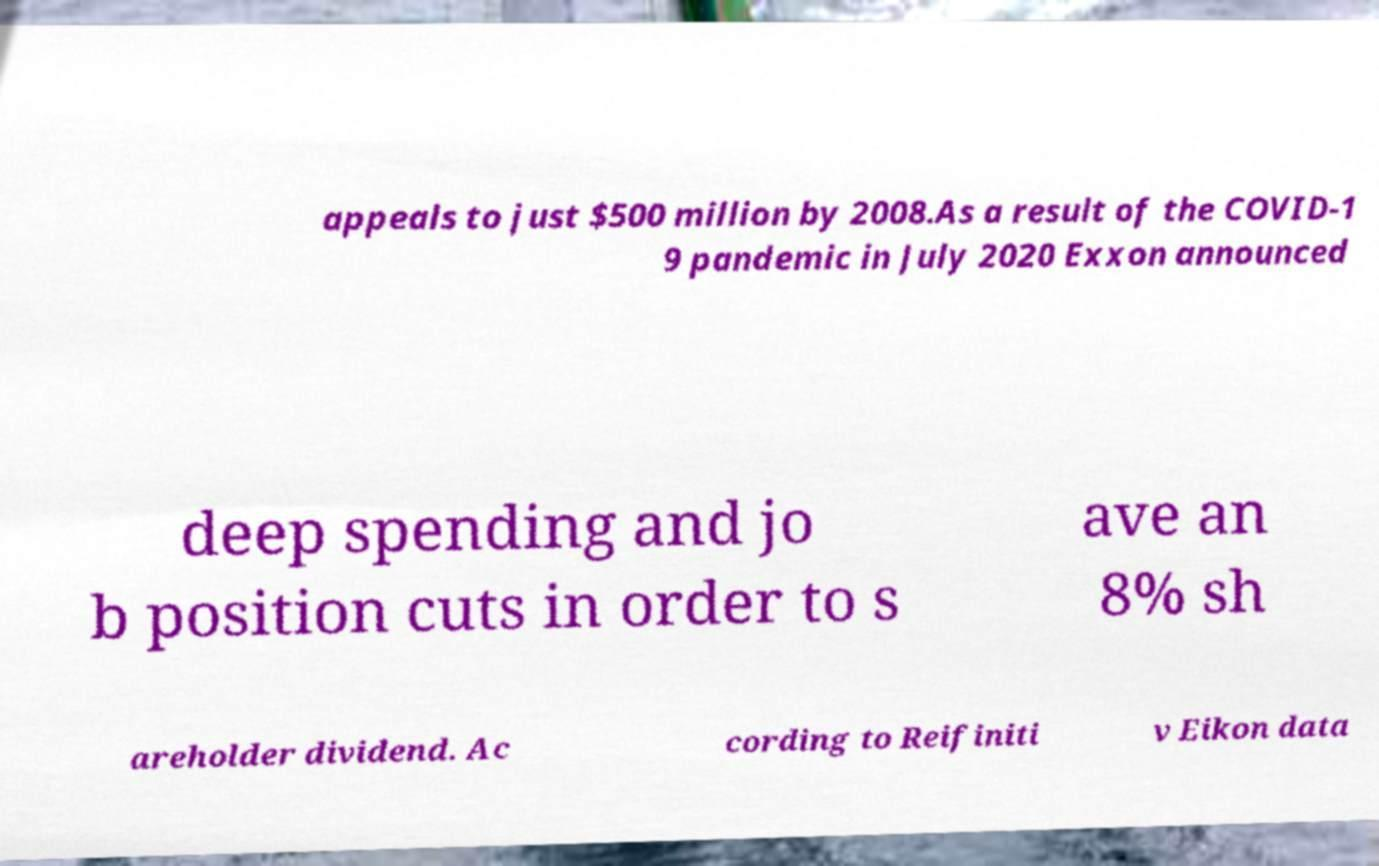For documentation purposes, I need the text within this image transcribed. Could you provide that? appeals to just $500 million by 2008.As a result of the COVID-1 9 pandemic in July 2020 Exxon announced deep spending and jo b position cuts in order to s ave an 8% sh areholder dividend. Ac cording to Reifiniti v Eikon data 